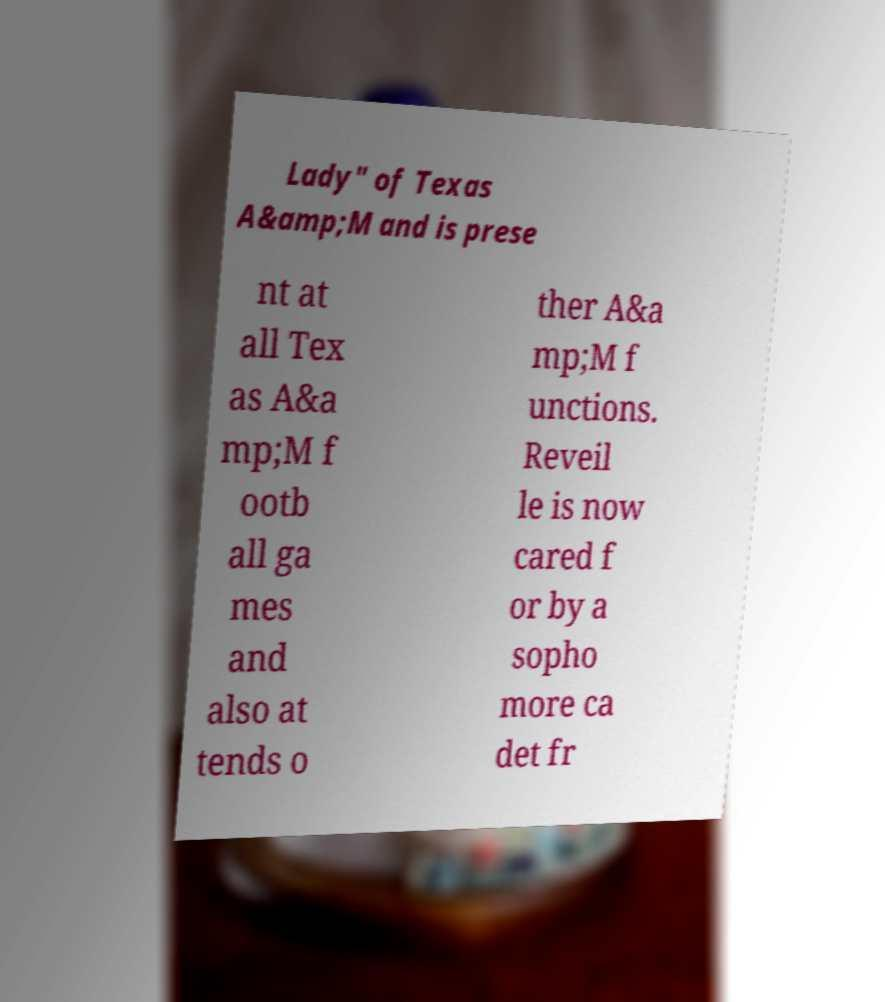For documentation purposes, I need the text within this image transcribed. Could you provide that? Lady" of Texas A&amp;M and is prese nt at all Tex as A&a mp;M f ootb all ga mes and also at tends o ther A&a mp;M f unctions. Reveil le is now cared f or by a sopho more ca det fr 